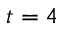Convert formula to latex. <formula><loc_0><loc_0><loc_500><loc_500>t = 4</formula> 